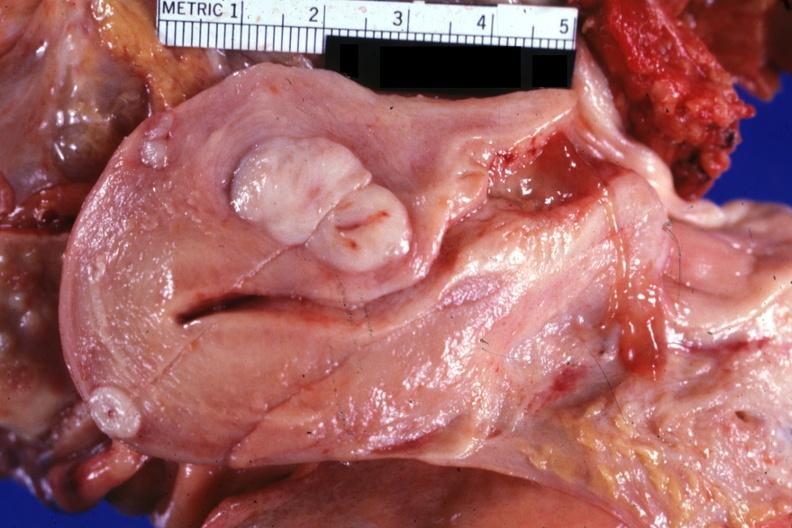does this image show opened uterus with three myomas quite typical?
Answer the question using a single word or phrase. Yes 